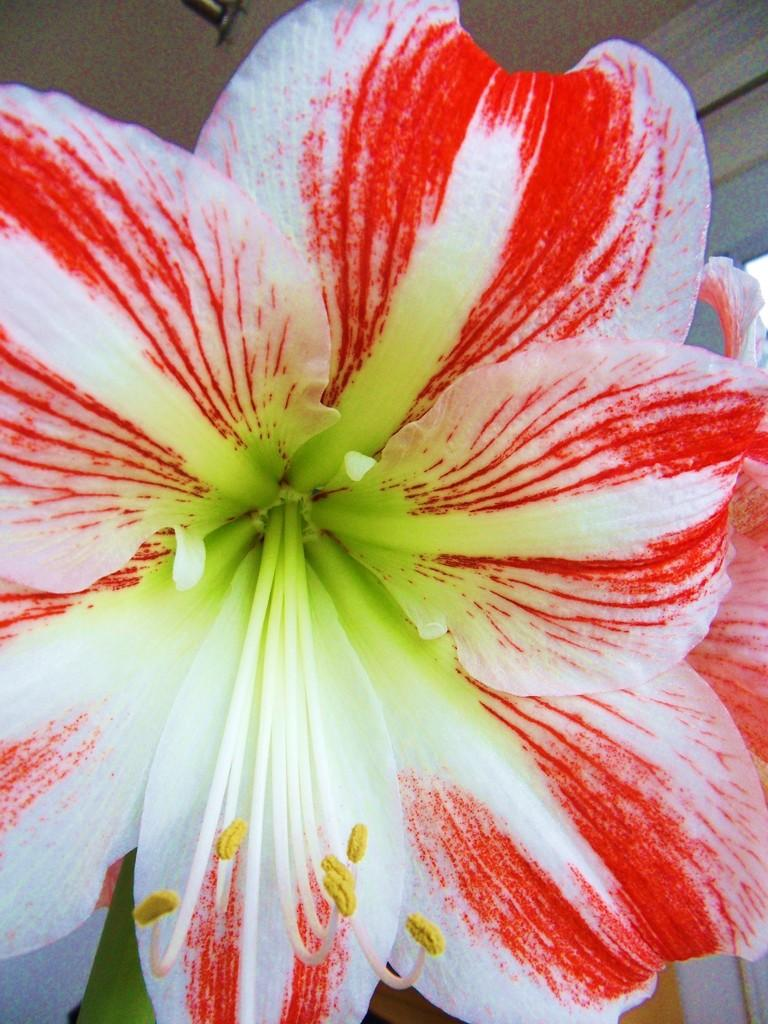What type of plants can be seen in the image? There are flowers in the image. What colors are the flowers? The flowers have white and red colors. What type of wound can be seen on the flower in the image? There is no wound present on the flowers in the image. 